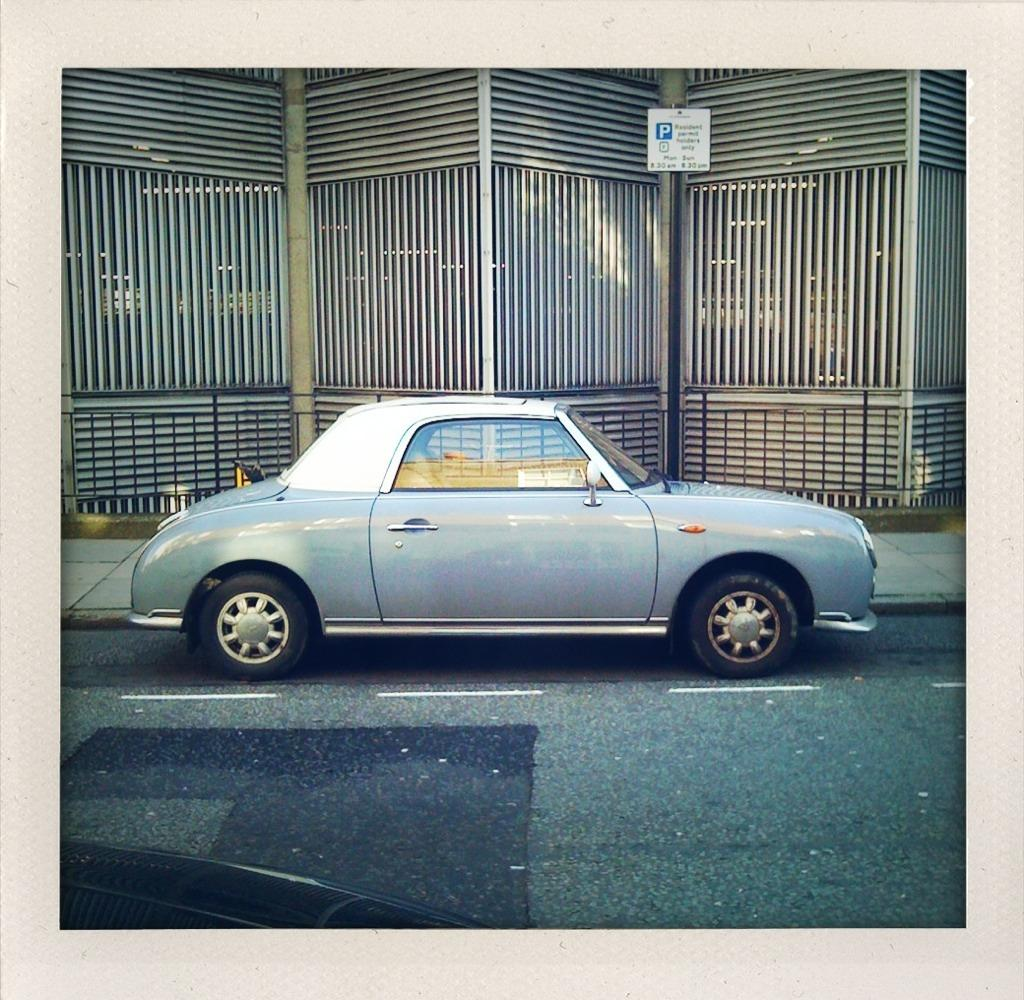What is parked on the road in the image? There is a car parked on the road in the image. What is located beside the road in the image? There is a walkway beside the road in the image. What can be seen in the background of the image? There is a wall of metal rods in the background of the image. What is written on the board attached to the metal rods? There is a board with text on the metal rods in the background of the image. What is the reason for the car's journey in the image? The image does not provide any information about the car's journey or reason for being there, so we cannot determine the reason from the image. 